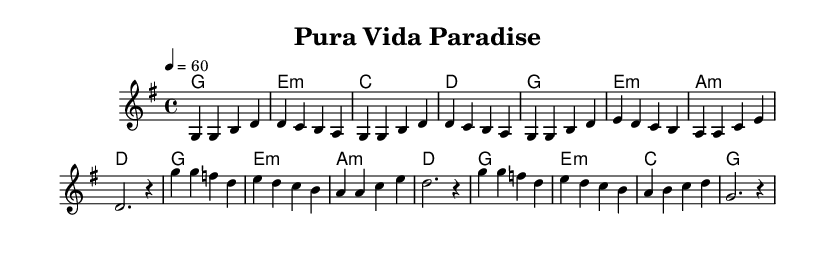What is the key signature of this music? The key signature is G major, which has one sharp (F#). You can determine this by looking at the key signature indicated at the beginning of the sheet music.
Answer: G major What is the time signature used in the piece? The time signature is 4/4, which means there are four beats in each measure. This is indicated at the beginning of the score, right after the key signature.
Answer: 4/4 What is the tempo marking for the piece? The tempo marking is 60 beats per minute. This is indicated at the beginning of the score, stating the tempo as '4 = 60'.
Answer: 60 How many measures are in the verse section? There are 8 measures in the verse section as indicated by the musical notation under the verse. Each grouping in the melody corresponds to a measure.
Answer: 8 What is the harmony type used throughout the score? The harmony type used is primarily triads, as shown in the chord progression outlined in the harmonies section. Each chord consists of three notes stacked based on the tonic, third, and fifth intervals.
Answer: Triads What is the last chord of the chorus? The last chord of the chorus is G major. This can be identified by looking at the harmonies section where the final chord is indicated.
Answer: G What musical genre is represented in this sheet music? The musical genre is Soul, characterized by its emotive style and focus on harmonies and melody, which is evident from the structure and style of the piece.
Answer: Soul 